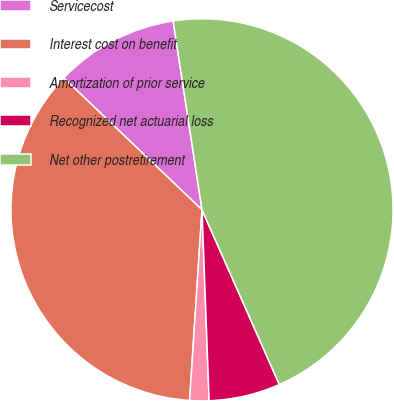Convert chart to OTSL. <chart><loc_0><loc_0><loc_500><loc_500><pie_chart><fcel>Servicecost<fcel>Interest cost on benefit<fcel>Amortization of prior service<fcel>Recognized net actuarial loss<fcel>Net other postretirement<nl><fcel>10.46%<fcel>36.09%<fcel>1.63%<fcel>6.04%<fcel>45.78%<nl></chart> 